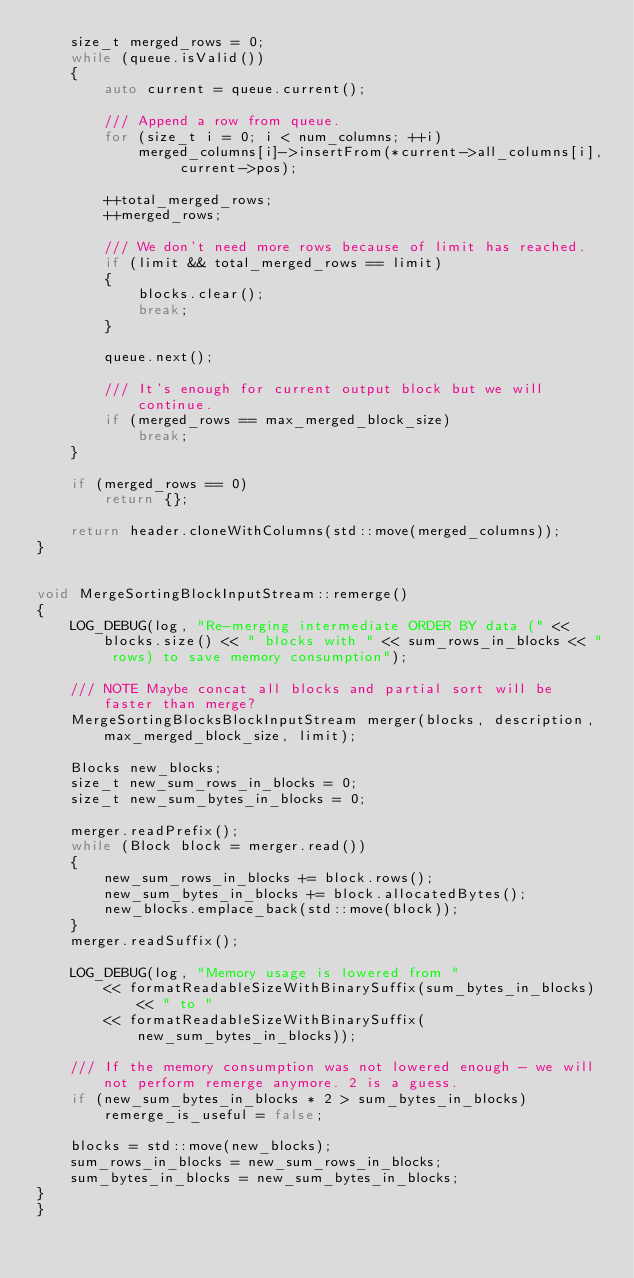<code> <loc_0><loc_0><loc_500><loc_500><_C++_>    size_t merged_rows = 0;
    while (queue.isValid())
    {
        auto current = queue.current();

        /// Append a row from queue.
        for (size_t i = 0; i < num_columns; ++i)
            merged_columns[i]->insertFrom(*current->all_columns[i], current->pos);

        ++total_merged_rows;
        ++merged_rows;

        /// We don't need more rows because of limit has reached.
        if (limit && total_merged_rows == limit)
        {
            blocks.clear();
            break;
        }

        queue.next();

        /// It's enough for current output block but we will continue.
        if (merged_rows == max_merged_block_size)
            break;
    }

    if (merged_rows == 0)
        return {};

    return header.cloneWithColumns(std::move(merged_columns));
}


void MergeSortingBlockInputStream::remerge()
{
    LOG_DEBUG(log, "Re-merging intermediate ORDER BY data (" << blocks.size() << " blocks with " << sum_rows_in_blocks << " rows) to save memory consumption");

    /// NOTE Maybe concat all blocks and partial sort will be faster than merge?
    MergeSortingBlocksBlockInputStream merger(blocks, description, max_merged_block_size, limit);

    Blocks new_blocks;
    size_t new_sum_rows_in_blocks = 0;
    size_t new_sum_bytes_in_blocks = 0;

    merger.readPrefix();
    while (Block block = merger.read())
    {
        new_sum_rows_in_blocks += block.rows();
        new_sum_bytes_in_blocks += block.allocatedBytes();
        new_blocks.emplace_back(std::move(block));
    }
    merger.readSuffix();

    LOG_DEBUG(log, "Memory usage is lowered from "
        << formatReadableSizeWithBinarySuffix(sum_bytes_in_blocks) << " to "
        << formatReadableSizeWithBinarySuffix(new_sum_bytes_in_blocks));

    /// If the memory consumption was not lowered enough - we will not perform remerge anymore. 2 is a guess.
    if (new_sum_bytes_in_blocks * 2 > sum_bytes_in_blocks)
        remerge_is_useful = false;

    blocks = std::move(new_blocks);
    sum_rows_in_blocks = new_sum_rows_in_blocks;
    sum_bytes_in_blocks = new_sum_bytes_in_blocks;
}
}
</code> 